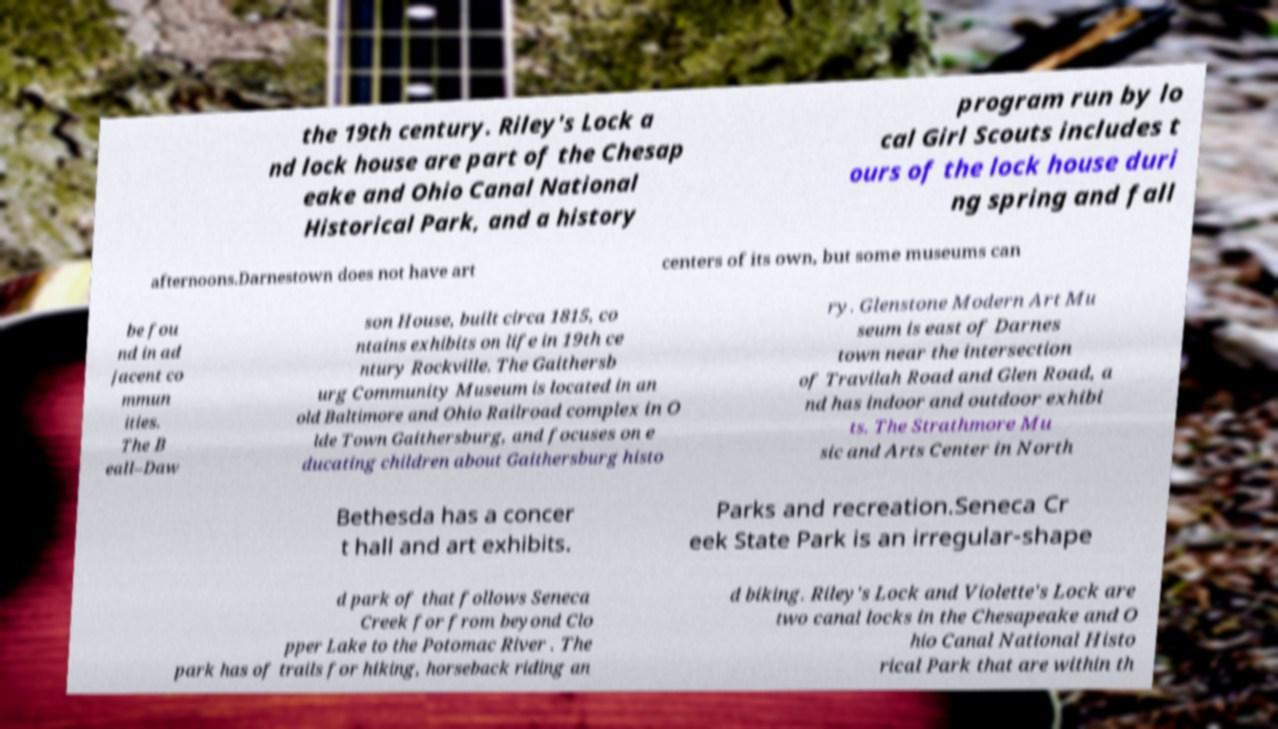For documentation purposes, I need the text within this image transcribed. Could you provide that? the 19th century. Riley's Lock a nd lock house are part of the Chesap eake and Ohio Canal National Historical Park, and a history program run by lo cal Girl Scouts includes t ours of the lock house duri ng spring and fall afternoons.Darnestown does not have art centers of its own, but some museums can be fou nd in ad jacent co mmun ities. The B eall–Daw son House, built circa 1815, co ntains exhibits on life in 19th ce ntury Rockville. The Gaithersb urg Community Museum is located in an old Baltimore and Ohio Railroad complex in O lde Town Gaithersburg, and focuses on e ducating children about Gaithersburg histo ry. Glenstone Modern Art Mu seum is east of Darnes town near the intersection of Travilah Road and Glen Road, a nd has indoor and outdoor exhibi ts. The Strathmore Mu sic and Arts Center in North Bethesda has a concer t hall and art exhibits. Parks and recreation.Seneca Cr eek State Park is an irregular-shape d park of that follows Seneca Creek for from beyond Clo pper Lake to the Potomac River . The park has of trails for hiking, horseback riding an d biking. Riley's Lock and Violette's Lock are two canal locks in the Chesapeake and O hio Canal National Histo rical Park that are within th 